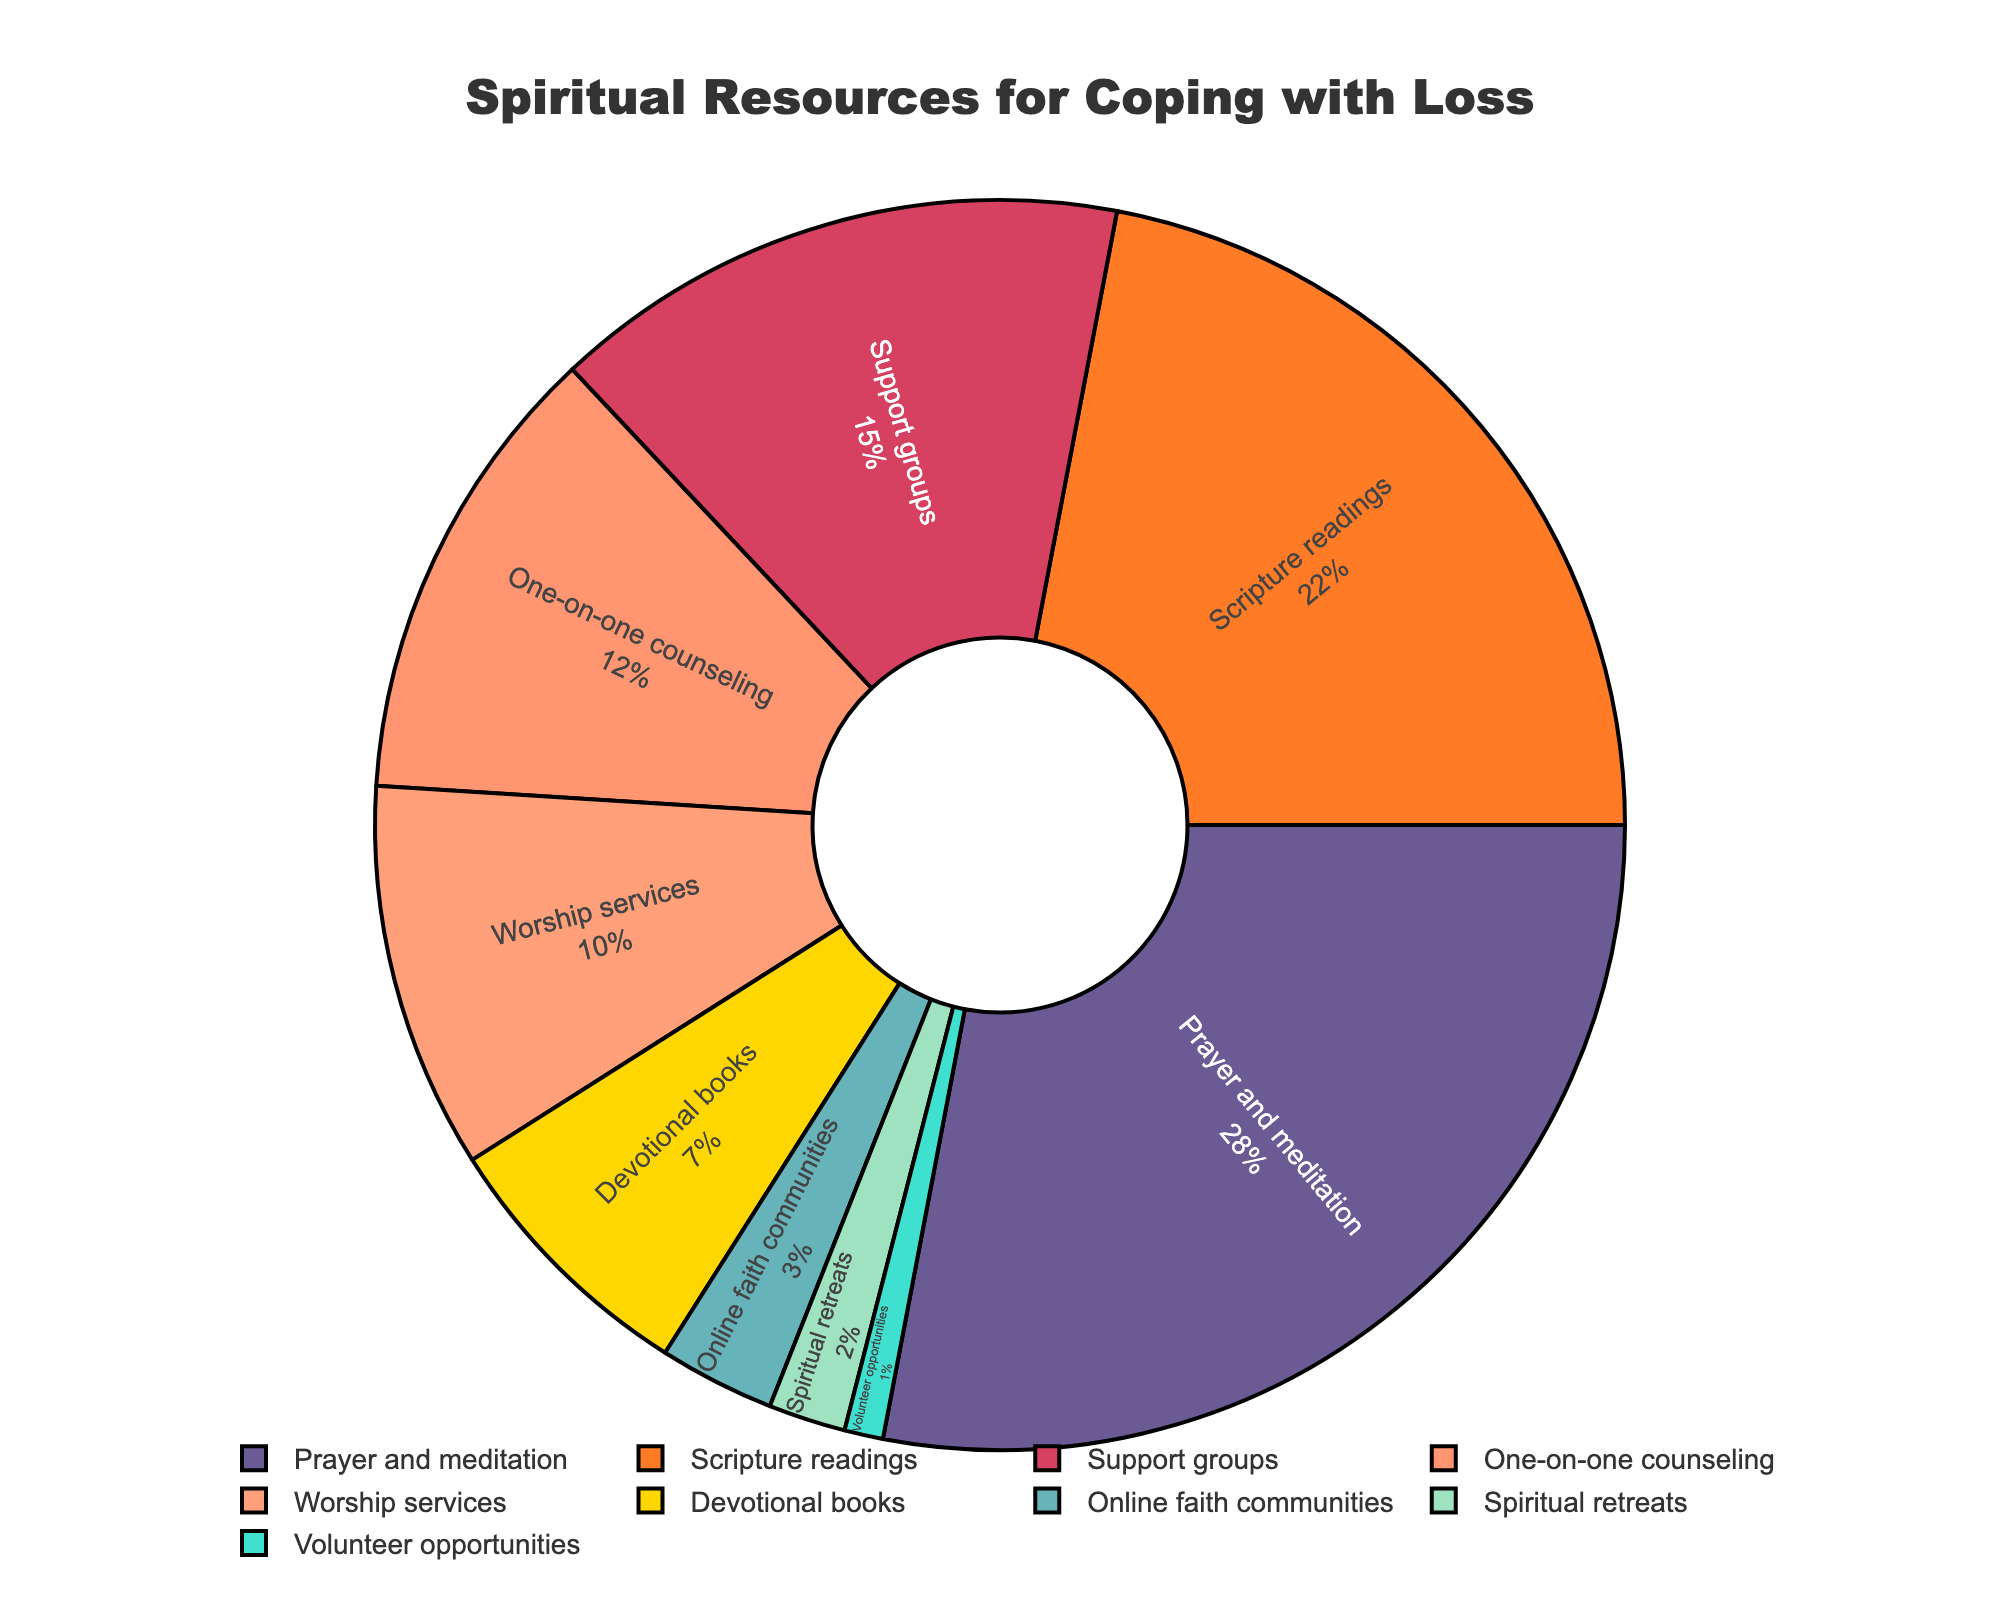What percentage of congregants find prayer and meditation helpful? By looking at the pie chart, identify the segment labeled "Prayer and meditation" and note its corresponding percentage.
Answer: 28% Which spiritual resource is the least utilized by congregants for coping with loss? Examine all the segments in the pie chart and find the one with the smallest percentage, which is labeled "Volunteer opportunities."
Answer: Volunteer opportunities Between "Scripture readings" and "Worship services," which is more popular and by how much? Find the segments labeled "Scripture readings" and "Worship services" in the pie chart. Compare their percentages (22% for "Scripture readings" and 10% for "Worship services") and subtract the smaller percentage from the larger one: 22% - 10%.
Answer: Scripture readings by 12% What is the total percentage of congregants finding support groups and one-on-one counseling helpful? Locate the segments for "Support groups" (15%) and "One-on-one counseling" (12%), and sum their percentages: 15% + 12%.
Answer: 27% How does the popularity of devotional books compare to online faith communities? Identify the segments for "Devotional books" (7%) and "Online faith communities" (3%), and compare their percentages.
Answer: Devotional books are more popular by 4% Which resource has a slightly higher percentage: Online faith communities or spiritual retreats? Look at the percentages for "Online faith communities" (3%) and "Spiritual retreats" (2%) and determine which is higher.
Answer: Online faith communities Does the combined percentage of prayer and meditation and scripture readings exceed 50%? Add the percentages for "Prayer and meditation" (28%) and "Scripture readings" (22%): 28% + 22%. Check if the sum is greater than 50%.
Answer: No, it is 50% How many resources have a percentage greater than 10%? Count all segments in the pie chart whose percentages are above 10%: "Prayer and meditation" (28%), "Scripture readings" (22%), "Support groups" (15%), and "One-on-one counseling" (12%).
Answer: Four resources Which spiritual resource is depicted in a deep purple color? Identify the segment colored in deep purple and note its label in the pie chart.
Answer: Prayer and meditation 